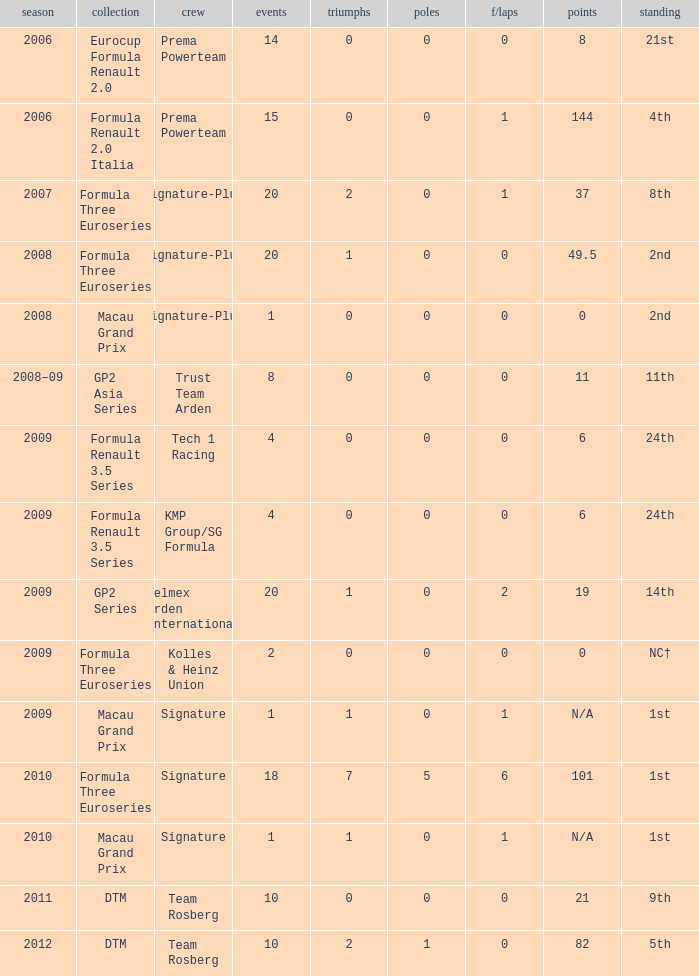I'm looking to parse the entire table for insights. Could you assist me with that? {'header': ['season', 'collection', 'crew', 'events', 'triumphs', 'poles', 'f/laps', 'points', 'standing'], 'rows': [['2006', 'Eurocup Formula Renault 2.0', 'Prema Powerteam', '14', '0', '0', '0', '8', '21st'], ['2006', 'Formula Renault 2.0 Italia', 'Prema Powerteam', '15', '0', '0', '1', '144', '4th'], ['2007', 'Formula Three Euroseries', 'Signature-Plus', '20', '2', '0', '1', '37', '8th'], ['2008', 'Formula Three Euroseries', 'Signature-Plus', '20', '1', '0', '0', '49.5', '2nd'], ['2008', 'Macau Grand Prix', 'Signature-Plus', '1', '0', '0', '0', '0', '2nd'], ['2008–09', 'GP2 Asia Series', 'Trust Team Arden', '8', '0', '0', '0', '11', '11th'], ['2009', 'Formula Renault 3.5 Series', 'Tech 1 Racing', '4', '0', '0', '0', '6', '24th'], ['2009', 'Formula Renault 3.5 Series', 'KMP Group/SG Formula', '4', '0', '0', '0', '6', '24th'], ['2009', 'GP2 Series', 'Telmex Arden International', '20', '1', '0', '2', '19', '14th'], ['2009', 'Formula Three Euroseries', 'Kolles & Heinz Union', '2', '0', '0', '0', '0', 'NC†'], ['2009', 'Macau Grand Prix', 'Signature', '1', '1', '0', '1', 'N/A', '1st'], ['2010', 'Formula Three Euroseries', 'Signature', '18', '7', '5', '6', '101', '1st'], ['2010', 'Macau Grand Prix', 'Signature', '1', '1', '0', '1', 'N/A', '1st'], ['2011', 'DTM', 'Team Rosberg', '10', '0', '0', '0', '21', '9th'], ['2012', 'DTM', 'Team Rosberg', '10', '2', '1', '0', '82', '5th']]} How many poles are there in the 2009 season with 2 races and more than 0 F/Laps? 0.0. 